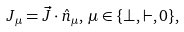<formula> <loc_0><loc_0><loc_500><loc_500>J _ { \mu } = \vec { J } \cdot \hat { n } _ { \mu } , \, \mu \in \{ \perp , \vdash , 0 \} ,</formula> 